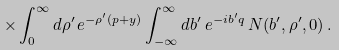Convert formula to latex. <formula><loc_0><loc_0><loc_500><loc_500>\times \int _ { 0 } ^ { \infty } d \rho ^ { \prime } \, e ^ { - \rho ^ { \prime } ( p + y ) } \int _ { - \infty } ^ { \infty } { d b } ^ { \prime } \, e ^ { - i b ^ { \prime } q } \, N ( b ^ { \prime } , \rho ^ { \prime } , 0 ) \, .</formula> 